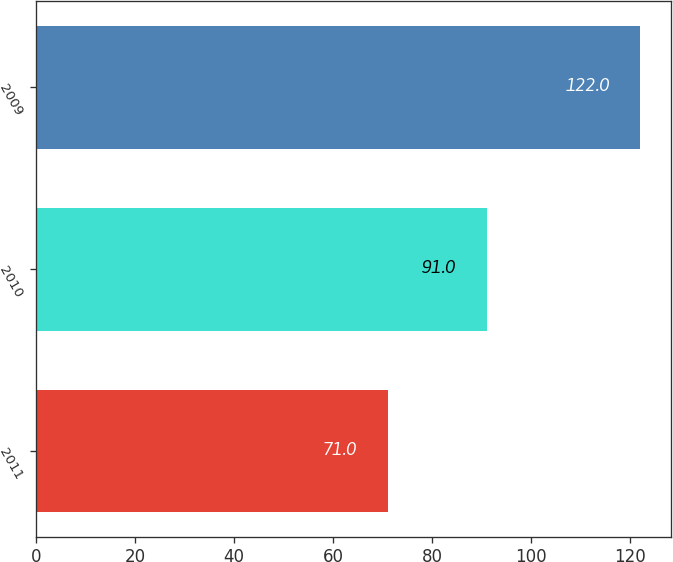Convert chart to OTSL. <chart><loc_0><loc_0><loc_500><loc_500><bar_chart><fcel>2011<fcel>2010<fcel>2009<nl><fcel>71<fcel>91<fcel>122<nl></chart> 